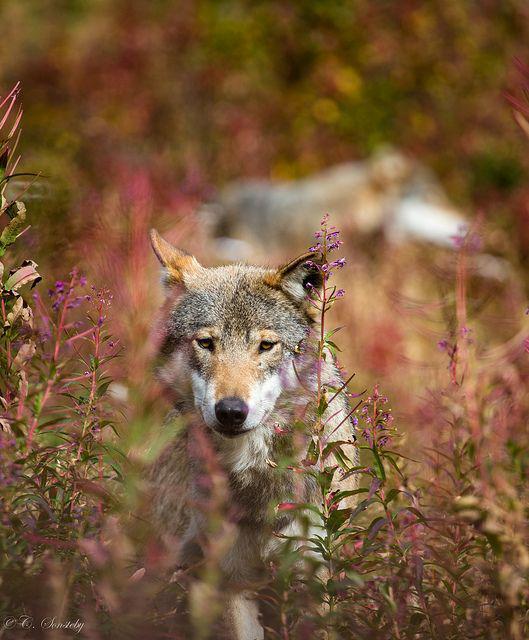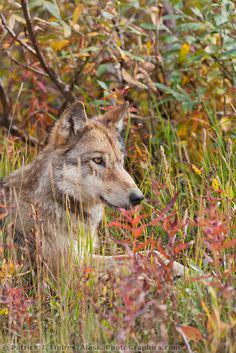The first image is the image on the left, the second image is the image on the right. Assess this claim about the two images: "Each image shows a single foreground wolf posed in a scene of colorful foliage.". Correct or not? Answer yes or no. Yes. The first image is the image on the left, the second image is the image on the right. Evaluate the accuracy of this statement regarding the images: "There are only two wolves and neither of them are howling.". Is it true? Answer yes or no. Yes. 